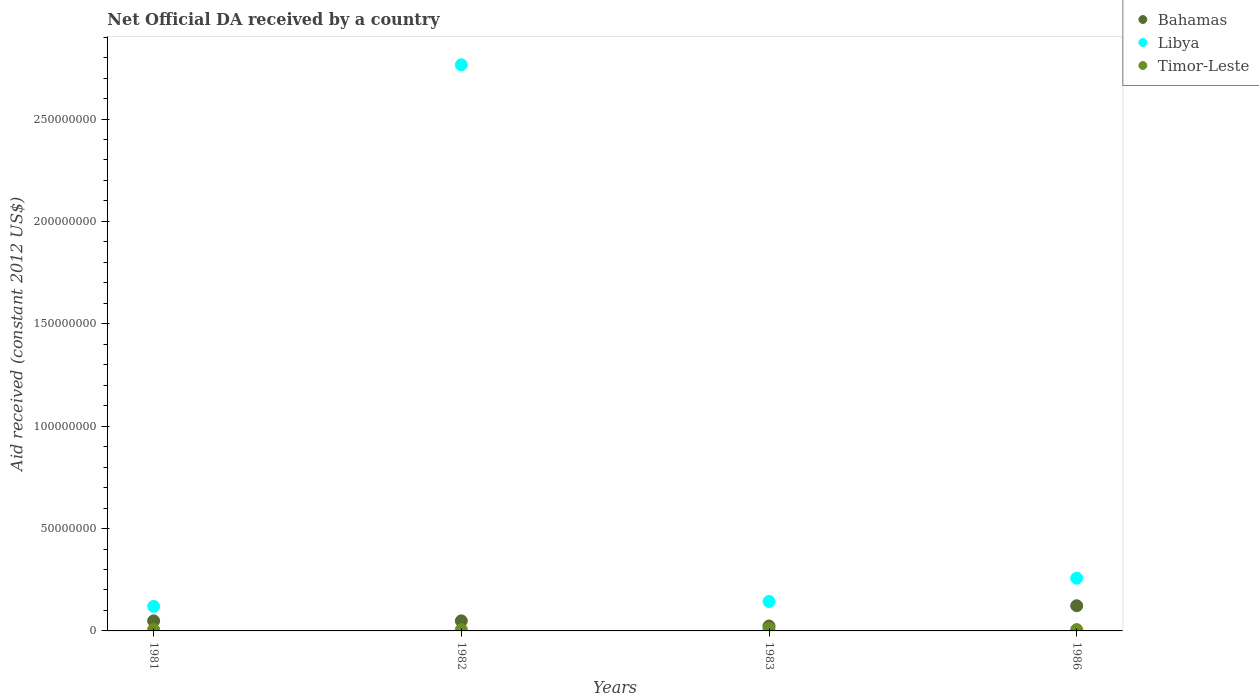What is the net official development assistance aid received in Timor-Leste in 1981?
Provide a succinct answer. 6.50e+05. Across all years, what is the maximum net official development assistance aid received in Libya?
Give a very brief answer. 2.76e+08. In which year was the net official development assistance aid received in Libya maximum?
Offer a very short reply. 1982. What is the total net official development assistance aid received in Bahamas in the graph?
Provide a short and direct response. 2.45e+07. What is the difference between the net official development assistance aid received in Bahamas in 1981 and that in 1982?
Your answer should be very brief. 0. What is the difference between the net official development assistance aid received in Libya in 1983 and the net official development assistance aid received in Bahamas in 1982?
Your answer should be compact. 9.46e+06. What is the average net official development assistance aid received in Libya per year?
Offer a terse response. 8.21e+07. In the year 1986, what is the difference between the net official development assistance aid received in Timor-Leste and net official development assistance aid received in Bahamas?
Your answer should be very brief. -1.16e+07. Is the net official development assistance aid received in Bahamas in 1982 less than that in 1983?
Your response must be concise. No. Is the difference between the net official development assistance aid received in Timor-Leste in 1982 and 1983 greater than the difference between the net official development assistance aid received in Bahamas in 1982 and 1983?
Offer a very short reply. No. What is the difference between the highest and the second highest net official development assistance aid received in Libya?
Provide a succinct answer. 2.51e+08. What is the difference between the highest and the lowest net official development assistance aid received in Timor-Leste?
Provide a short and direct response. 6.10e+05. In how many years, is the net official development assistance aid received in Bahamas greater than the average net official development assistance aid received in Bahamas taken over all years?
Make the answer very short. 1. Is it the case that in every year, the sum of the net official development assistance aid received in Timor-Leste and net official development assistance aid received in Bahamas  is greater than the net official development assistance aid received in Libya?
Provide a succinct answer. No. Is the net official development assistance aid received in Bahamas strictly less than the net official development assistance aid received in Libya over the years?
Provide a succinct answer. Yes. How many dotlines are there?
Your response must be concise. 3. How many years are there in the graph?
Provide a short and direct response. 4. What is the difference between two consecutive major ticks on the Y-axis?
Your response must be concise. 5.00e+07. Are the values on the major ticks of Y-axis written in scientific E-notation?
Make the answer very short. No. Does the graph contain grids?
Offer a terse response. No. Where does the legend appear in the graph?
Provide a short and direct response. Top right. How are the legend labels stacked?
Provide a succinct answer. Vertical. What is the title of the graph?
Provide a succinct answer. Net Official DA received by a country. What is the label or title of the Y-axis?
Offer a very short reply. Aid received (constant 2012 US$). What is the Aid received (constant 2012 US$) in Bahamas in 1981?
Your answer should be compact. 4.91e+06. What is the Aid received (constant 2012 US$) in Libya in 1981?
Your response must be concise. 1.20e+07. What is the Aid received (constant 2012 US$) in Timor-Leste in 1981?
Provide a short and direct response. 6.50e+05. What is the Aid received (constant 2012 US$) of Bahamas in 1982?
Your answer should be very brief. 4.91e+06. What is the Aid received (constant 2012 US$) in Libya in 1982?
Your answer should be compact. 2.76e+08. What is the Aid received (constant 2012 US$) in Timor-Leste in 1982?
Your answer should be very brief. 6.00e+05. What is the Aid received (constant 2012 US$) in Bahamas in 1983?
Offer a very short reply. 2.41e+06. What is the Aid received (constant 2012 US$) in Libya in 1983?
Ensure brevity in your answer.  1.44e+07. What is the Aid received (constant 2012 US$) in Timor-Leste in 1983?
Provide a succinct answer. 1.21e+06. What is the Aid received (constant 2012 US$) in Bahamas in 1986?
Offer a very short reply. 1.23e+07. What is the Aid received (constant 2012 US$) in Libya in 1986?
Your answer should be very brief. 2.58e+07. What is the Aid received (constant 2012 US$) in Timor-Leste in 1986?
Keep it short and to the point. 6.50e+05. Across all years, what is the maximum Aid received (constant 2012 US$) of Bahamas?
Ensure brevity in your answer.  1.23e+07. Across all years, what is the maximum Aid received (constant 2012 US$) of Libya?
Give a very brief answer. 2.76e+08. Across all years, what is the maximum Aid received (constant 2012 US$) in Timor-Leste?
Your response must be concise. 1.21e+06. Across all years, what is the minimum Aid received (constant 2012 US$) of Bahamas?
Provide a succinct answer. 2.41e+06. Across all years, what is the minimum Aid received (constant 2012 US$) in Libya?
Give a very brief answer. 1.20e+07. Across all years, what is the minimum Aid received (constant 2012 US$) of Timor-Leste?
Your answer should be very brief. 6.00e+05. What is the total Aid received (constant 2012 US$) in Bahamas in the graph?
Your answer should be very brief. 2.45e+07. What is the total Aid received (constant 2012 US$) of Libya in the graph?
Your answer should be very brief. 3.29e+08. What is the total Aid received (constant 2012 US$) of Timor-Leste in the graph?
Keep it short and to the point. 3.11e+06. What is the difference between the Aid received (constant 2012 US$) in Libya in 1981 and that in 1982?
Offer a very short reply. -2.64e+08. What is the difference between the Aid received (constant 2012 US$) of Timor-Leste in 1981 and that in 1982?
Provide a succinct answer. 5.00e+04. What is the difference between the Aid received (constant 2012 US$) in Bahamas in 1981 and that in 1983?
Provide a succinct answer. 2.50e+06. What is the difference between the Aid received (constant 2012 US$) of Libya in 1981 and that in 1983?
Provide a short and direct response. -2.41e+06. What is the difference between the Aid received (constant 2012 US$) of Timor-Leste in 1981 and that in 1983?
Keep it short and to the point. -5.60e+05. What is the difference between the Aid received (constant 2012 US$) of Bahamas in 1981 and that in 1986?
Give a very brief answer. -7.39e+06. What is the difference between the Aid received (constant 2012 US$) in Libya in 1981 and that in 1986?
Make the answer very short. -1.38e+07. What is the difference between the Aid received (constant 2012 US$) in Bahamas in 1982 and that in 1983?
Ensure brevity in your answer.  2.50e+06. What is the difference between the Aid received (constant 2012 US$) of Libya in 1982 and that in 1983?
Make the answer very short. 2.62e+08. What is the difference between the Aid received (constant 2012 US$) of Timor-Leste in 1982 and that in 1983?
Ensure brevity in your answer.  -6.10e+05. What is the difference between the Aid received (constant 2012 US$) in Bahamas in 1982 and that in 1986?
Keep it short and to the point. -7.39e+06. What is the difference between the Aid received (constant 2012 US$) of Libya in 1982 and that in 1986?
Offer a terse response. 2.51e+08. What is the difference between the Aid received (constant 2012 US$) in Timor-Leste in 1982 and that in 1986?
Offer a very short reply. -5.00e+04. What is the difference between the Aid received (constant 2012 US$) of Bahamas in 1983 and that in 1986?
Your response must be concise. -9.89e+06. What is the difference between the Aid received (constant 2012 US$) of Libya in 1983 and that in 1986?
Provide a succinct answer. -1.14e+07. What is the difference between the Aid received (constant 2012 US$) of Timor-Leste in 1983 and that in 1986?
Keep it short and to the point. 5.60e+05. What is the difference between the Aid received (constant 2012 US$) of Bahamas in 1981 and the Aid received (constant 2012 US$) of Libya in 1982?
Provide a succinct answer. -2.72e+08. What is the difference between the Aid received (constant 2012 US$) of Bahamas in 1981 and the Aid received (constant 2012 US$) of Timor-Leste in 1982?
Provide a short and direct response. 4.31e+06. What is the difference between the Aid received (constant 2012 US$) in Libya in 1981 and the Aid received (constant 2012 US$) in Timor-Leste in 1982?
Your answer should be compact. 1.14e+07. What is the difference between the Aid received (constant 2012 US$) of Bahamas in 1981 and the Aid received (constant 2012 US$) of Libya in 1983?
Your response must be concise. -9.46e+06. What is the difference between the Aid received (constant 2012 US$) in Bahamas in 1981 and the Aid received (constant 2012 US$) in Timor-Leste in 1983?
Offer a very short reply. 3.70e+06. What is the difference between the Aid received (constant 2012 US$) of Libya in 1981 and the Aid received (constant 2012 US$) of Timor-Leste in 1983?
Provide a succinct answer. 1.08e+07. What is the difference between the Aid received (constant 2012 US$) of Bahamas in 1981 and the Aid received (constant 2012 US$) of Libya in 1986?
Ensure brevity in your answer.  -2.08e+07. What is the difference between the Aid received (constant 2012 US$) in Bahamas in 1981 and the Aid received (constant 2012 US$) in Timor-Leste in 1986?
Give a very brief answer. 4.26e+06. What is the difference between the Aid received (constant 2012 US$) in Libya in 1981 and the Aid received (constant 2012 US$) in Timor-Leste in 1986?
Offer a terse response. 1.13e+07. What is the difference between the Aid received (constant 2012 US$) of Bahamas in 1982 and the Aid received (constant 2012 US$) of Libya in 1983?
Your answer should be compact. -9.46e+06. What is the difference between the Aid received (constant 2012 US$) in Bahamas in 1982 and the Aid received (constant 2012 US$) in Timor-Leste in 1983?
Your answer should be compact. 3.70e+06. What is the difference between the Aid received (constant 2012 US$) in Libya in 1982 and the Aid received (constant 2012 US$) in Timor-Leste in 1983?
Your answer should be compact. 2.75e+08. What is the difference between the Aid received (constant 2012 US$) in Bahamas in 1982 and the Aid received (constant 2012 US$) in Libya in 1986?
Give a very brief answer. -2.08e+07. What is the difference between the Aid received (constant 2012 US$) in Bahamas in 1982 and the Aid received (constant 2012 US$) in Timor-Leste in 1986?
Give a very brief answer. 4.26e+06. What is the difference between the Aid received (constant 2012 US$) of Libya in 1982 and the Aid received (constant 2012 US$) of Timor-Leste in 1986?
Provide a short and direct response. 2.76e+08. What is the difference between the Aid received (constant 2012 US$) in Bahamas in 1983 and the Aid received (constant 2012 US$) in Libya in 1986?
Offer a terse response. -2.33e+07. What is the difference between the Aid received (constant 2012 US$) of Bahamas in 1983 and the Aid received (constant 2012 US$) of Timor-Leste in 1986?
Give a very brief answer. 1.76e+06. What is the difference between the Aid received (constant 2012 US$) of Libya in 1983 and the Aid received (constant 2012 US$) of Timor-Leste in 1986?
Your answer should be very brief. 1.37e+07. What is the average Aid received (constant 2012 US$) in Bahamas per year?
Provide a succinct answer. 6.13e+06. What is the average Aid received (constant 2012 US$) of Libya per year?
Give a very brief answer. 8.21e+07. What is the average Aid received (constant 2012 US$) of Timor-Leste per year?
Your answer should be very brief. 7.78e+05. In the year 1981, what is the difference between the Aid received (constant 2012 US$) of Bahamas and Aid received (constant 2012 US$) of Libya?
Keep it short and to the point. -7.05e+06. In the year 1981, what is the difference between the Aid received (constant 2012 US$) of Bahamas and Aid received (constant 2012 US$) of Timor-Leste?
Give a very brief answer. 4.26e+06. In the year 1981, what is the difference between the Aid received (constant 2012 US$) of Libya and Aid received (constant 2012 US$) of Timor-Leste?
Your answer should be compact. 1.13e+07. In the year 1982, what is the difference between the Aid received (constant 2012 US$) in Bahamas and Aid received (constant 2012 US$) in Libya?
Offer a very short reply. -2.72e+08. In the year 1982, what is the difference between the Aid received (constant 2012 US$) in Bahamas and Aid received (constant 2012 US$) in Timor-Leste?
Your answer should be very brief. 4.31e+06. In the year 1982, what is the difference between the Aid received (constant 2012 US$) in Libya and Aid received (constant 2012 US$) in Timor-Leste?
Give a very brief answer. 2.76e+08. In the year 1983, what is the difference between the Aid received (constant 2012 US$) of Bahamas and Aid received (constant 2012 US$) of Libya?
Offer a very short reply. -1.20e+07. In the year 1983, what is the difference between the Aid received (constant 2012 US$) of Bahamas and Aid received (constant 2012 US$) of Timor-Leste?
Offer a terse response. 1.20e+06. In the year 1983, what is the difference between the Aid received (constant 2012 US$) in Libya and Aid received (constant 2012 US$) in Timor-Leste?
Your answer should be compact. 1.32e+07. In the year 1986, what is the difference between the Aid received (constant 2012 US$) in Bahamas and Aid received (constant 2012 US$) in Libya?
Keep it short and to the point. -1.34e+07. In the year 1986, what is the difference between the Aid received (constant 2012 US$) in Bahamas and Aid received (constant 2012 US$) in Timor-Leste?
Keep it short and to the point. 1.16e+07. In the year 1986, what is the difference between the Aid received (constant 2012 US$) of Libya and Aid received (constant 2012 US$) of Timor-Leste?
Keep it short and to the point. 2.51e+07. What is the ratio of the Aid received (constant 2012 US$) of Libya in 1981 to that in 1982?
Offer a terse response. 0.04. What is the ratio of the Aid received (constant 2012 US$) in Bahamas in 1981 to that in 1983?
Ensure brevity in your answer.  2.04. What is the ratio of the Aid received (constant 2012 US$) of Libya in 1981 to that in 1983?
Provide a short and direct response. 0.83. What is the ratio of the Aid received (constant 2012 US$) in Timor-Leste in 1981 to that in 1983?
Give a very brief answer. 0.54. What is the ratio of the Aid received (constant 2012 US$) of Bahamas in 1981 to that in 1986?
Keep it short and to the point. 0.4. What is the ratio of the Aid received (constant 2012 US$) in Libya in 1981 to that in 1986?
Your answer should be very brief. 0.46. What is the ratio of the Aid received (constant 2012 US$) in Bahamas in 1982 to that in 1983?
Keep it short and to the point. 2.04. What is the ratio of the Aid received (constant 2012 US$) in Libya in 1982 to that in 1983?
Your answer should be very brief. 19.24. What is the ratio of the Aid received (constant 2012 US$) in Timor-Leste in 1982 to that in 1983?
Provide a short and direct response. 0.5. What is the ratio of the Aid received (constant 2012 US$) in Bahamas in 1982 to that in 1986?
Ensure brevity in your answer.  0.4. What is the ratio of the Aid received (constant 2012 US$) in Libya in 1982 to that in 1986?
Ensure brevity in your answer.  10.74. What is the ratio of the Aid received (constant 2012 US$) in Bahamas in 1983 to that in 1986?
Provide a short and direct response. 0.2. What is the ratio of the Aid received (constant 2012 US$) in Libya in 1983 to that in 1986?
Your response must be concise. 0.56. What is the ratio of the Aid received (constant 2012 US$) in Timor-Leste in 1983 to that in 1986?
Your response must be concise. 1.86. What is the difference between the highest and the second highest Aid received (constant 2012 US$) in Bahamas?
Your response must be concise. 7.39e+06. What is the difference between the highest and the second highest Aid received (constant 2012 US$) in Libya?
Ensure brevity in your answer.  2.51e+08. What is the difference between the highest and the second highest Aid received (constant 2012 US$) of Timor-Leste?
Give a very brief answer. 5.60e+05. What is the difference between the highest and the lowest Aid received (constant 2012 US$) in Bahamas?
Make the answer very short. 9.89e+06. What is the difference between the highest and the lowest Aid received (constant 2012 US$) in Libya?
Keep it short and to the point. 2.64e+08. 